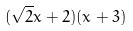<formula> <loc_0><loc_0><loc_500><loc_500>( \sqrt { 2 } x + 2 ) ( x + 3 )</formula> 